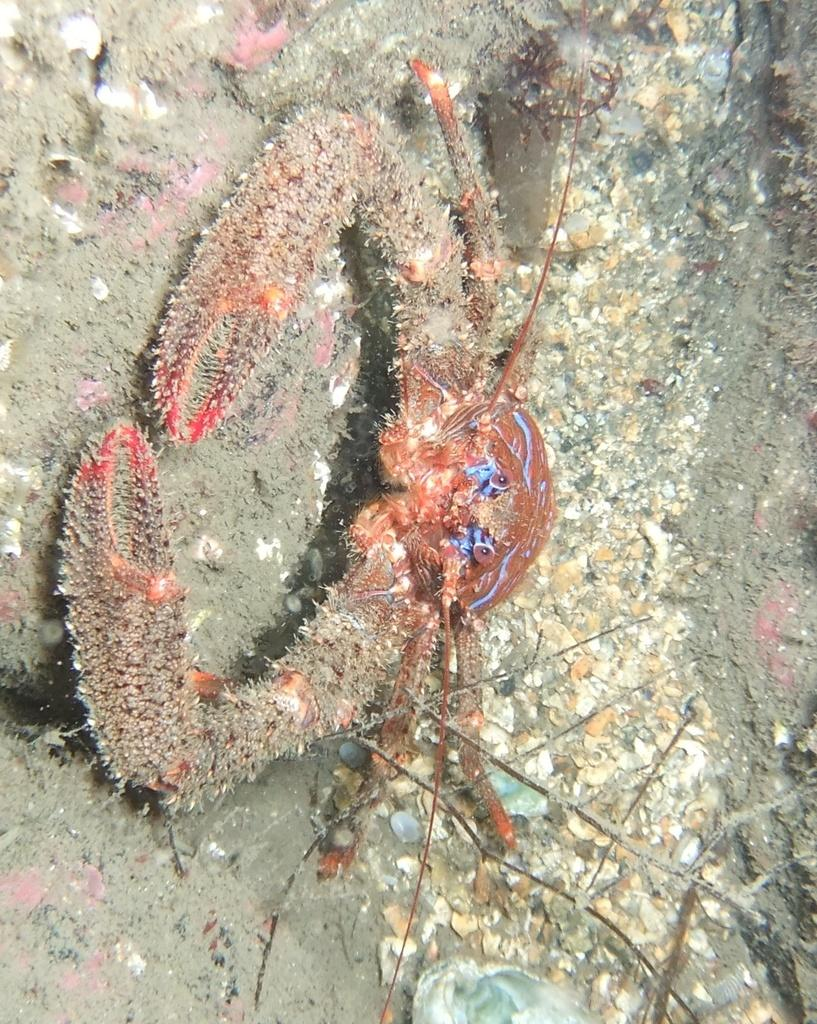Where is the picture taken? The picture is taken in water. What is the main subject in the center of the image? There is a crab in the center of the image. What other object can be seen at the bottom of the image? There is an oyster shell at the bottom of the image. What type of bun is being used as a prop in the image? There is no bun present in the image; it features a crab and an oyster shell in water. Can you see a plane flying in the background of the image? There is no plane visible in the image; it is taken underwater with a crab and an oyster shell. 